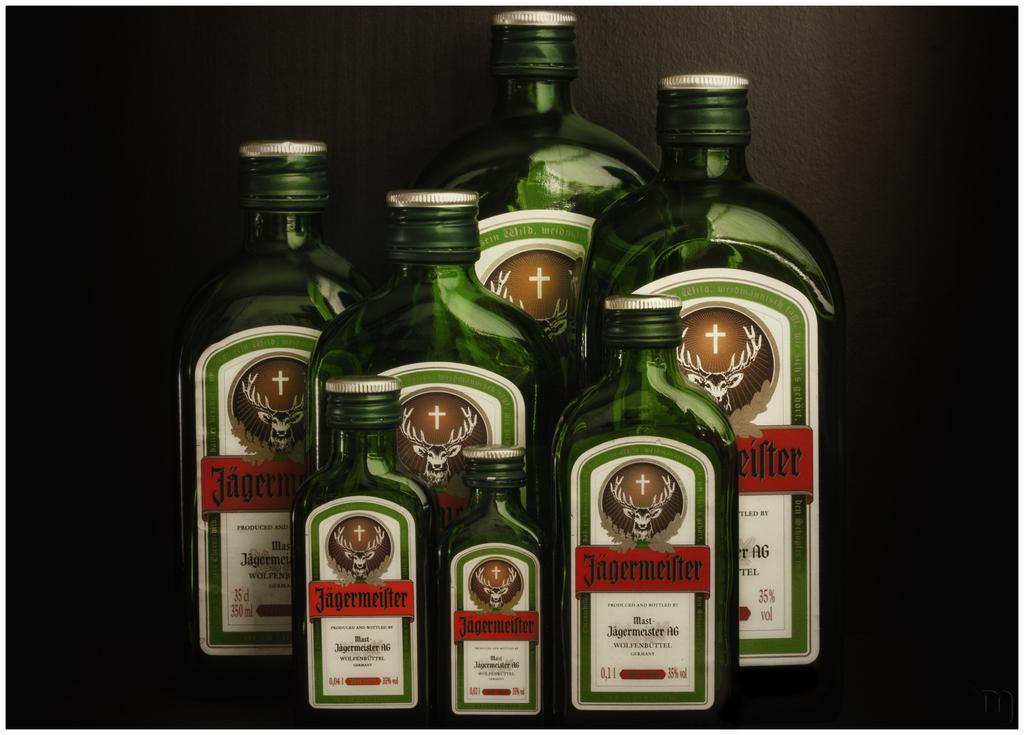<image>
Share a concise interpretation of the image provided. Several bottles of Jagermeister, which is claimed to be from Germany. 